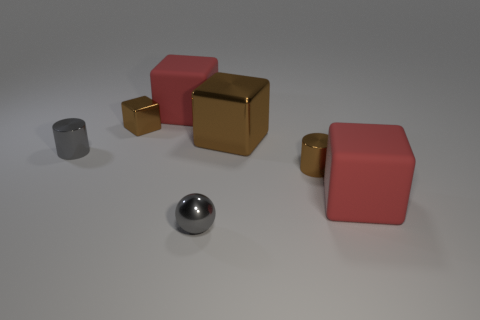There is a large rubber cube that is in front of the big brown cube; is it the same color as the matte cube that is left of the large brown cube?
Make the answer very short. Yes. There is a rubber block right of the brown cylinder; does it have the same size as the large brown metallic thing?
Offer a very short reply. Yes. How many objects are either tiny green shiny cubes or big red things?
Provide a short and direct response. 2. What shape is the small metallic thing that is the same color as the shiny ball?
Offer a very short reply. Cylinder. There is a thing that is both to the left of the tiny sphere and in front of the small cube; how big is it?
Provide a short and direct response. Small. What number of large red rubber things are there?
Offer a terse response. 2. How many balls are big red matte things or small gray shiny objects?
Offer a very short reply. 1. How many cylinders are behind the tiny brown metallic thing on the right side of the sphere to the right of the small gray metallic cylinder?
Provide a succinct answer. 1. There is a metal block that is the same size as the gray shiny cylinder; what color is it?
Make the answer very short. Brown. How many other objects are there of the same color as the sphere?
Keep it short and to the point. 1. 